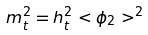<formula> <loc_0><loc_0><loc_500><loc_500>m ^ { 2 } _ { t } = h ^ { 2 } _ { t } < \phi _ { 2 } > ^ { 2 }</formula> 